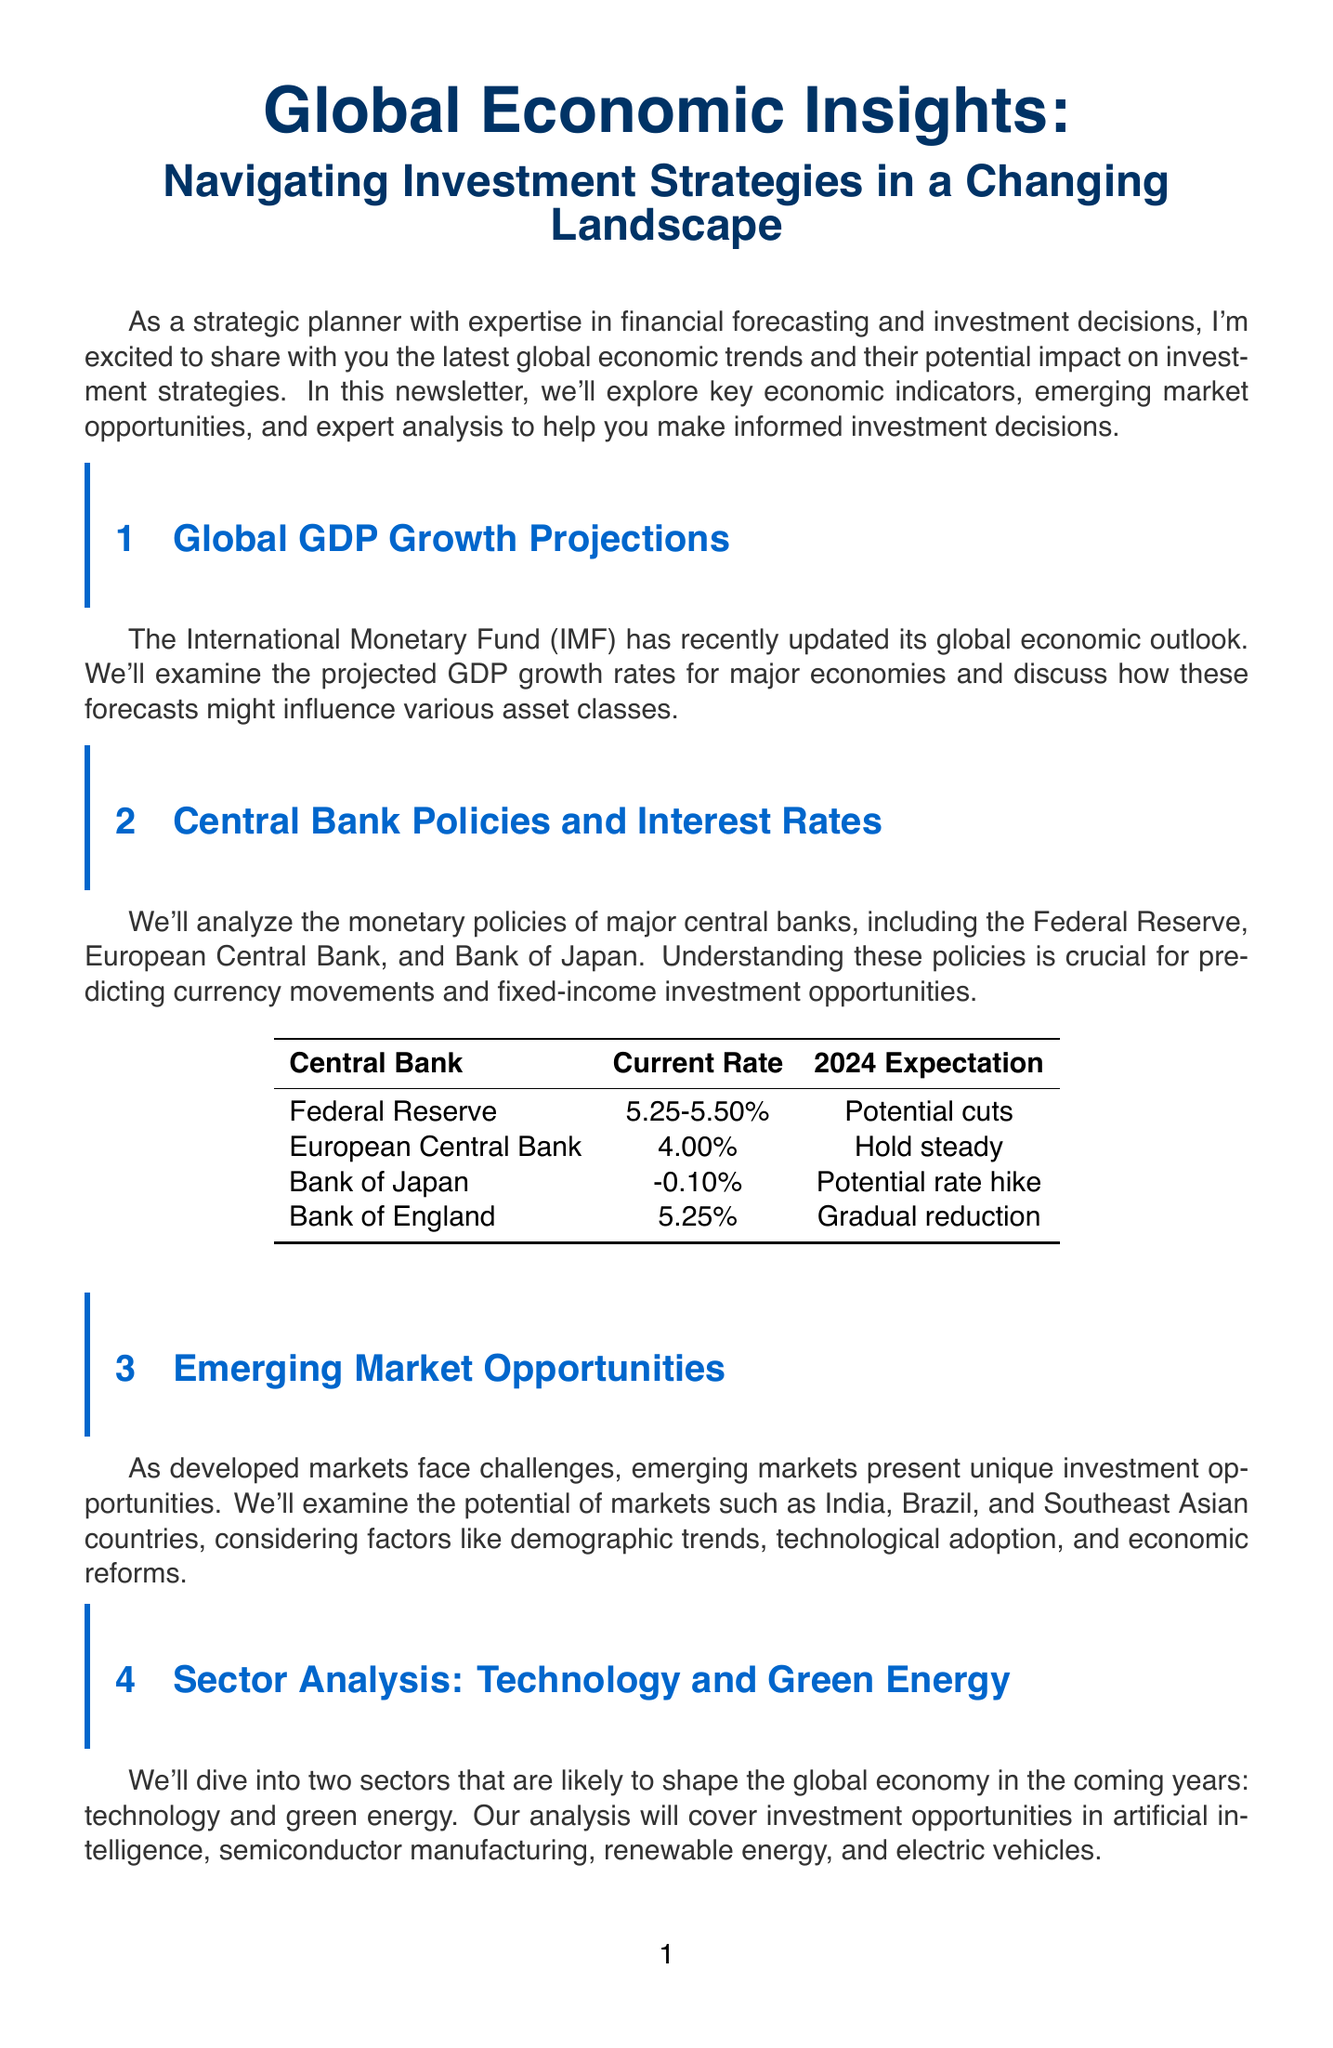What is the title of the newsletter? The title of the newsletter is stated at the beginning of the document, highlighting its focus on global economic insights and investment strategies.
Answer: Global Economic Insights: Navigating Investment Strategies in a Changing Landscape What is the projected GDP growth rate for India in 2024? The GDP growth rate for India in 2024 is specified in the GDP growth projections section of the document.
Answer: 6.3 Which central bank has a current rate of 4.00%? The current policy rates of central banks are provided in a table within the document.
Answer: European Central Bank What is the most attractive emerging market according to the Investment Attractiveness Index? The Heat Map section of the document scores various countries based on their attractiveness for investment, highlighting the top scores.
Answer: India What is the projected annual growth rate for Renewable Energy from 2023 to 2028? The growth rates for various sectors are indicated in a bar chart section of the document, detailing their respective projections.
Answer: 8.5 Who is the expert providing analysis in the newsletter? An expert opinion section provides insights from a recognized authority in economics, identifying who they are.
Answer: Dr. Nouriel Roubini What percentage of safe-haven asset allocation is in Gold? The percentage allocation for safe-haven assets is presented in a pie chart, specifying the distribution of different assets during uncertain times.
Answer: 30 What is the future expectation of the Bank of Japan's interest rate policy? Future expectations for central bank policies, including potential rate changes, are included in the table of current policy rates.
Answer: Potential rate hike 